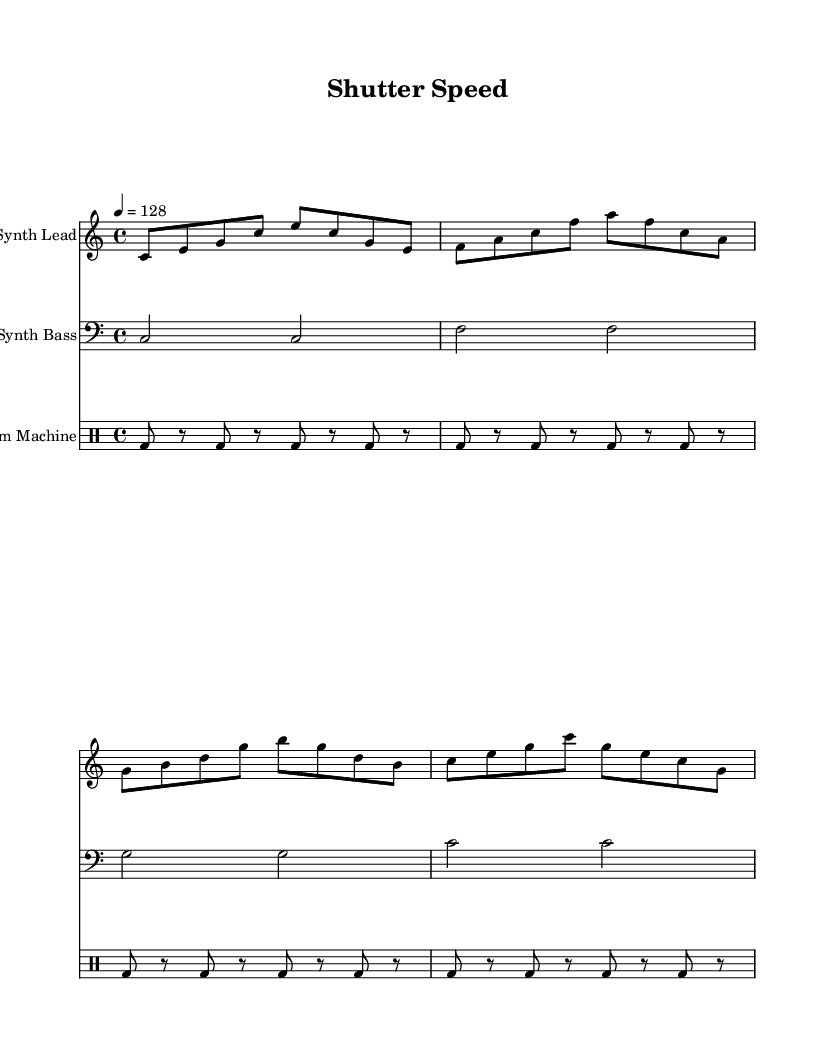What is the key signature of this music? The key signature is indicated by the absence of sharps or flats, which means it is in C major.
Answer: C major What is the time signature of this music? The time signature is shown by the notation at the beginning, which is 4/4, indicating four beats per measure.
Answer: 4/4 What is the tempo marking of this piece? The tempo is indicated by the number below the tempo marking, which says 4 = 128, meaning the piece should be played at a speed of 128 beats per minute.
Answer: 128 How many measures are in the synth lead part? Counting the segments divided by the vertical lines (bar lines), there are a total of four measures in the synth lead.
Answer: 4 What type of instrument is indicated for the synth bass? The clef used for the synth bass staff is the bass clef, which typically indicates a lower-range instrument, hence it suggests it's a bass instrument.
Answer: Bass How many times does the bass note 'C' appear in the synth bass part? In the synth bass section, 'C' appears a total of four times, as each measure contains two half notes of 'C'. Counting each half note from the four measures gives us four occurrences.
Answer: 4 What type of rhythm pattern does the drum machine use? The drum machine utilizes a consistent rhythm pattern consisting of a bass drum hit followed by rests, which creates a driving, repetitive rhythm typical in electronic music.
Answer: Repetitive rhythm 